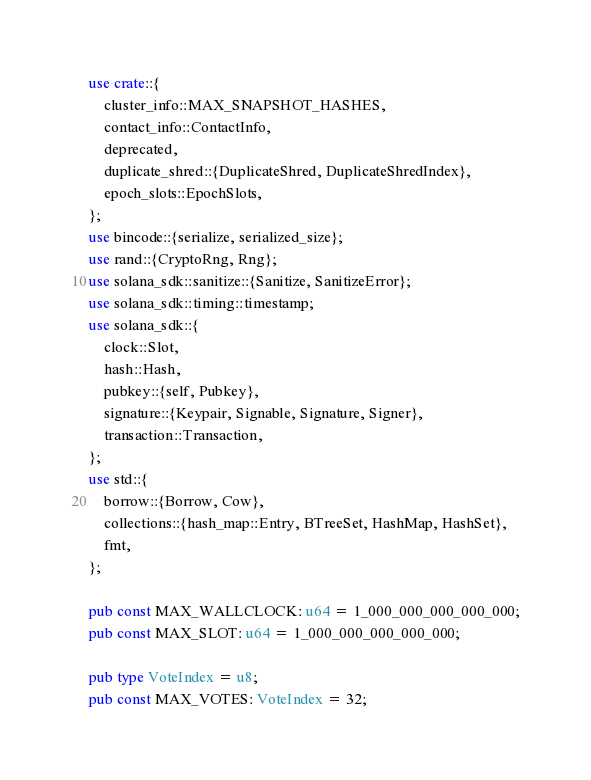Convert code to text. <code><loc_0><loc_0><loc_500><loc_500><_Rust_>use crate::{
    cluster_info::MAX_SNAPSHOT_HASHES,
    contact_info::ContactInfo,
    deprecated,
    duplicate_shred::{DuplicateShred, DuplicateShredIndex},
    epoch_slots::EpochSlots,
};
use bincode::{serialize, serialized_size};
use rand::{CryptoRng, Rng};
use solana_sdk::sanitize::{Sanitize, SanitizeError};
use solana_sdk::timing::timestamp;
use solana_sdk::{
    clock::Slot,
    hash::Hash,
    pubkey::{self, Pubkey},
    signature::{Keypair, Signable, Signature, Signer},
    transaction::Transaction,
};
use std::{
    borrow::{Borrow, Cow},
    collections::{hash_map::Entry, BTreeSet, HashMap, HashSet},
    fmt,
};

pub const MAX_WALLCLOCK: u64 = 1_000_000_000_000_000;
pub const MAX_SLOT: u64 = 1_000_000_000_000_000;

pub type VoteIndex = u8;
pub const MAX_VOTES: VoteIndex = 32;
</code> 